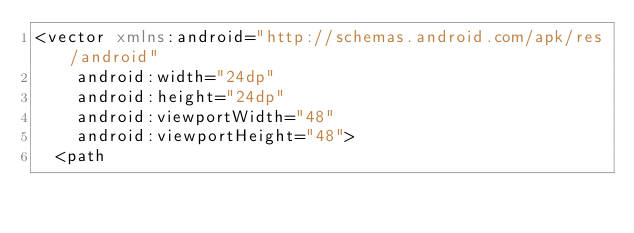<code> <loc_0><loc_0><loc_500><loc_500><_XML_><vector xmlns:android="http://schemas.android.com/apk/res/android"
    android:width="24dp"
    android:height="24dp"
    android:viewportWidth="48"
    android:viewportHeight="48">
  <path</code> 